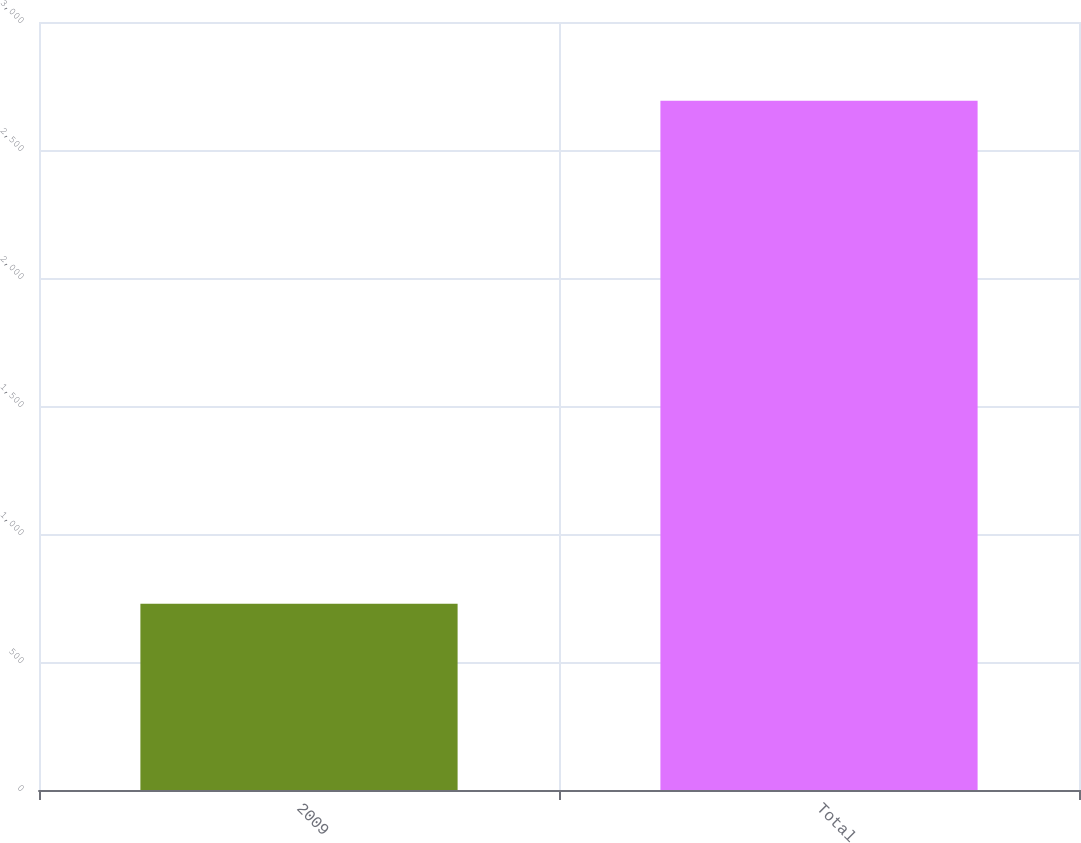Convert chart to OTSL. <chart><loc_0><loc_0><loc_500><loc_500><bar_chart><fcel>2009<fcel>Total<nl><fcel>728<fcel>2692<nl></chart> 